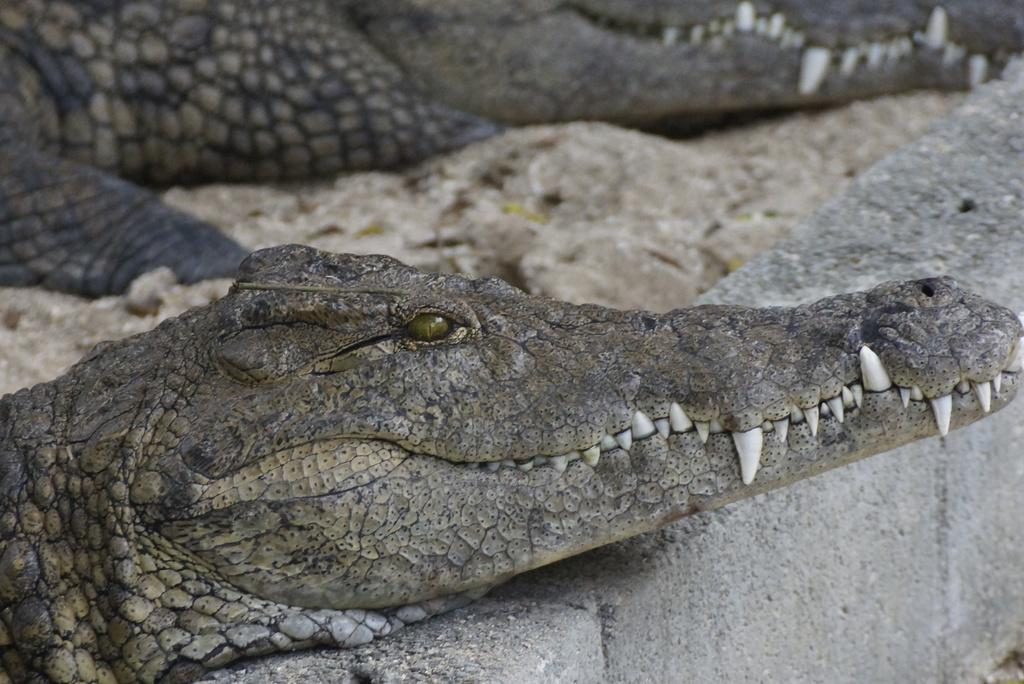What type of animals are in the image? There are crocodiles in the image. What can be seen beneath the animals? The ground is visible in the image. What material is present in the image? There are cement bricks in the image. What historical event is being guided by the crocodiles in the image? There is no historical event or guide present in the image; it simply features crocodiles and other elements. 